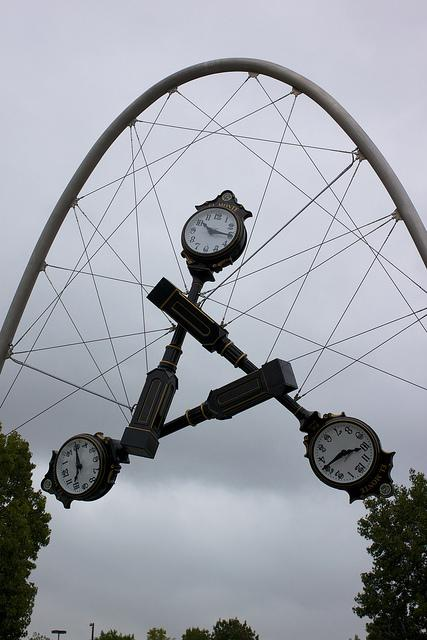Why are the clocks all facing different directions?

Choices:
A) easier reading
B) gimmick
C) broken
D) different times gimmick 